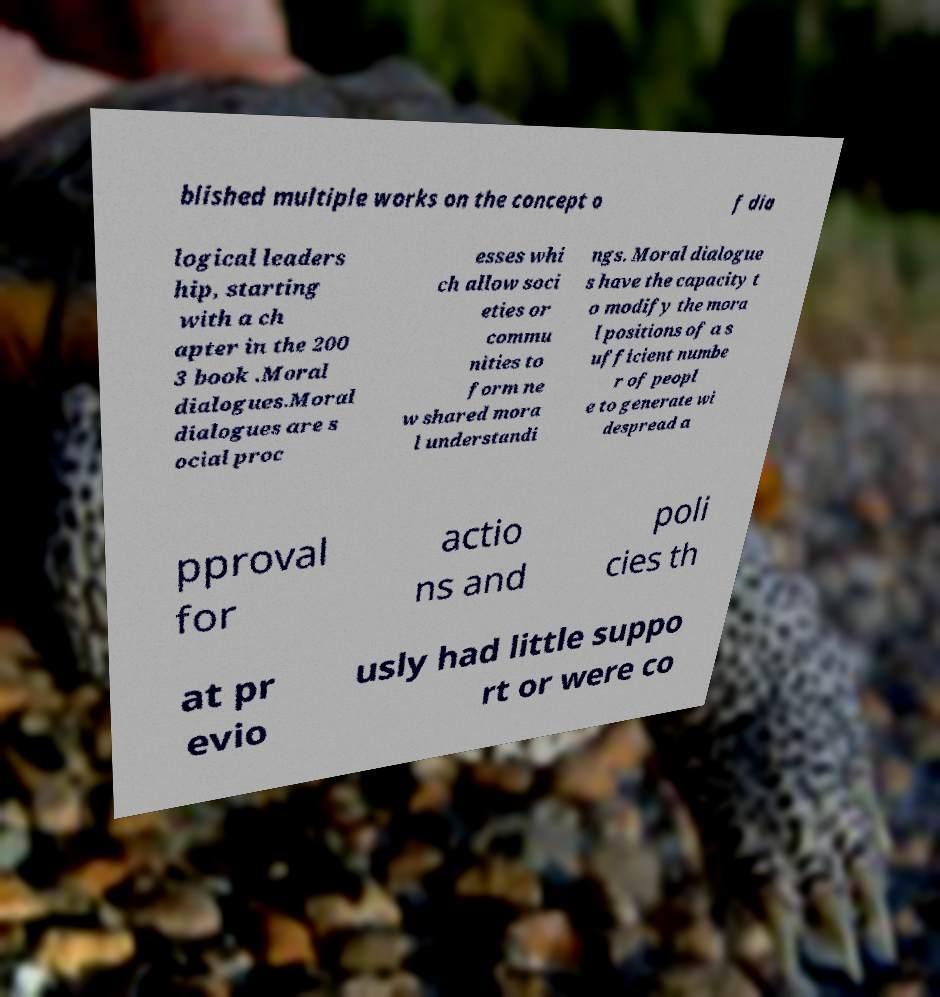Can you accurately transcribe the text from the provided image for me? blished multiple works on the concept o f dia logical leaders hip, starting with a ch apter in the 200 3 book .Moral dialogues.Moral dialogues are s ocial proc esses whi ch allow soci eties or commu nities to form ne w shared mora l understandi ngs. Moral dialogue s have the capacity t o modify the mora l positions of a s ufficient numbe r of peopl e to generate wi despread a pproval for actio ns and poli cies th at pr evio usly had little suppo rt or were co 